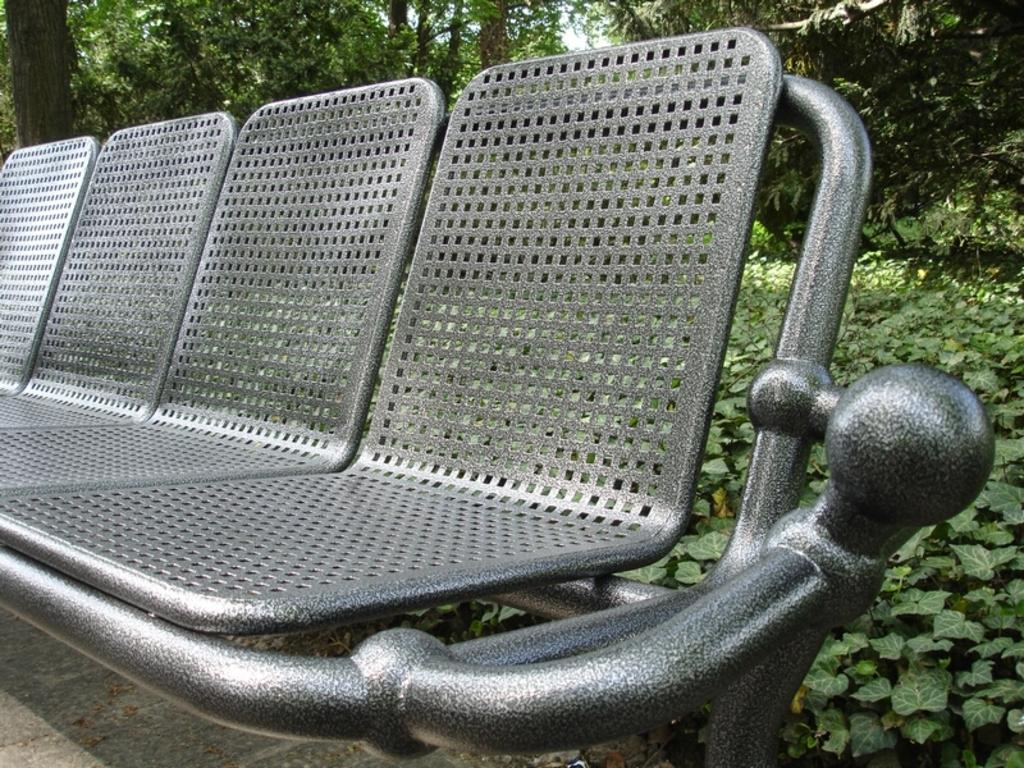What type of seating is visible in the image? There is a bench in the image. Where is the bench located? The bench is on the ground. What can be seen in the background of the image? There are trees in the background of the image. What type of cannon is located on top of the bench in the image? There is no cannon present in the image, and the bench is on the ground, not on top of anything. 